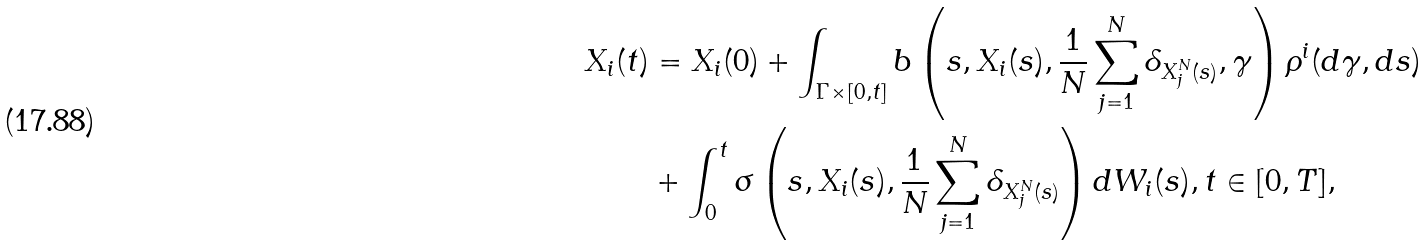<formula> <loc_0><loc_0><loc_500><loc_500>X _ { i } ( t ) & = X _ { i } ( 0 ) + \int _ { \Gamma \times [ 0 , t ] } b \left ( s , X _ { i } ( s ) , \frac { 1 } { N } \sum _ { j = 1 } ^ { N } \delta _ { X ^ { N } _ { j } ( s ) } , \gamma \right ) \rho ^ { i } ( d \gamma , d s ) \\ & + \int _ { 0 } ^ { t } \sigma \left ( s , X _ { i } ( s ) , \frac { 1 } { N } \sum _ { j = 1 } ^ { N } \delta _ { X ^ { N } _ { j } ( s ) } \right ) d W _ { i } ( s ) , t \in [ 0 , T ] ,</formula> 